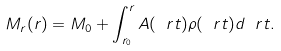Convert formula to latex. <formula><loc_0><loc_0><loc_500><loc_500>M _ { r } ( r ) = M _ { 0 } + \int _ { r _ { 0 } } ^ { r } A ( \ r t ) \rho ( \ r t ) d \ r t .</formula> 